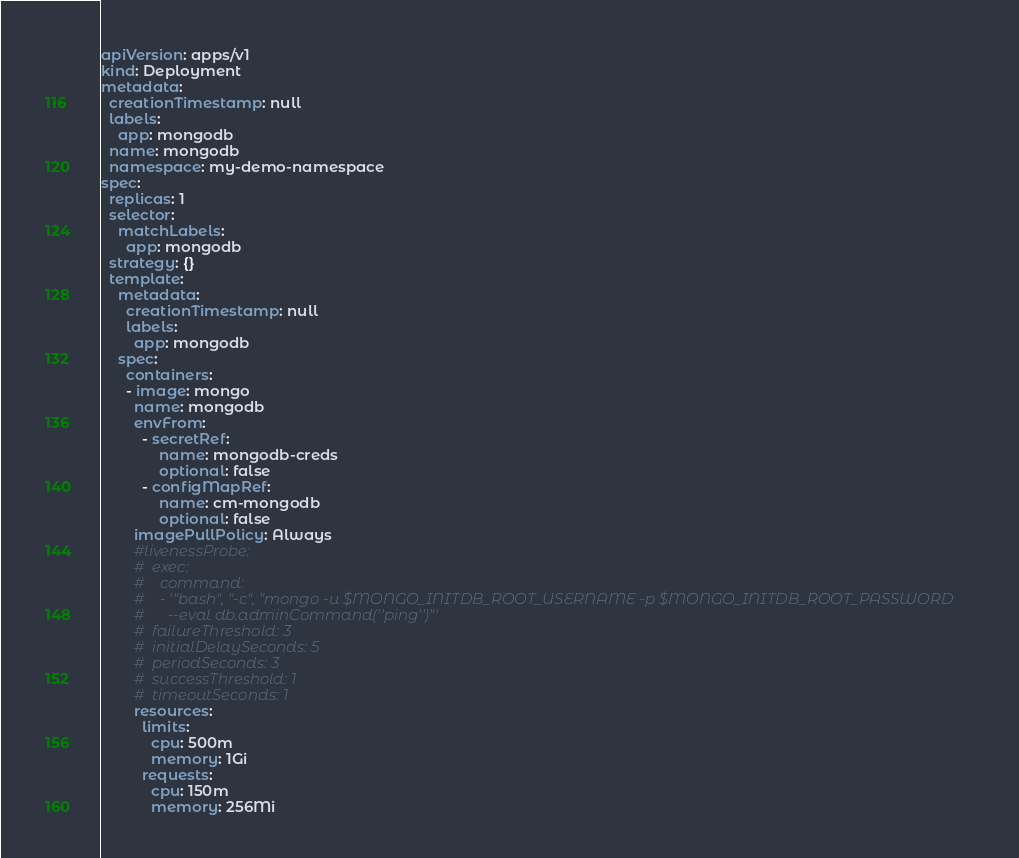<code> <loc_0><loc_0><loc_500><loc_500><_YAML_>apiVersion: apps/v1
kind: Deployment
metadata:
  creationTimestamp: null
  labels:
    app: mongodb
  name: mongodb
  namespace: my-demo-namespace
spec:
  replicas: 1
  selector:
    matchLabels:
      app: mongodb
  strategy: {}
  template:
    metadata:
      creationTimestamp: null
      labels:
        app: mongodb
    spec:
      containers:
      - image: mongo
        name: mongodb
        envFrom:
          - secretRef:
              name: mongodb-creds
              optional: false
          - configMapRef:
              name: cm-mongodb
              optional: false
        imagePullPolicy: Always
        #livenessProbe:
        #  exec:
        #    command:
        #    - '"bash", "-c", "mongo -u $MONGO_INITDB_ROOT_USERNAME -p $MONGO_INITDB_ROOT_PASSWORD
        #      --eval db.adminCommand(''ping'')"'
        #  failureThreshold: 3
        #  initialDelaySeconds: 5
        #  periodSeconds: 3
        #  successThreshold: 1
        #  timeoutSeconds: 1
        resources:
          limits:
            cpu: 500m
            memory: 1Gi
          requests:
            cpu: 150m
            memory: 256Mi</code> 